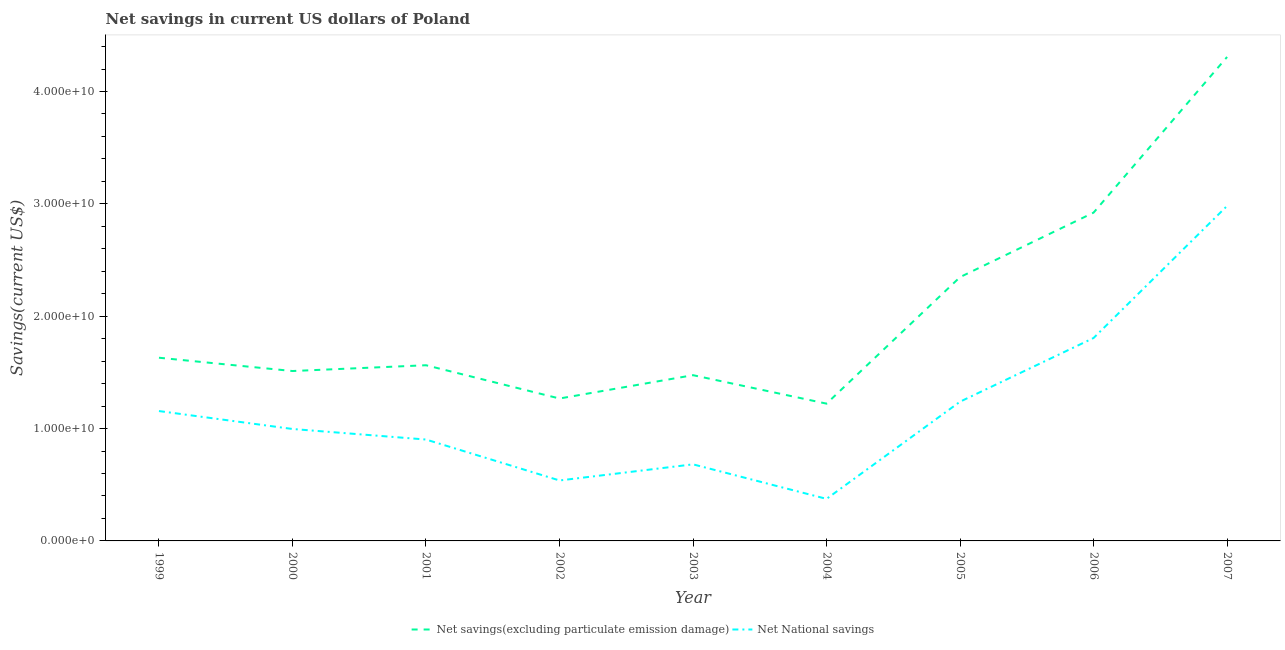Does the line corresponding to net national savings intersect with the line corresponding to net savings(excluding particulate emission damage)?
Ensure brevity in your answer.  No. What is the net national savings in 2002?
Provide a short and direct response. 5.38e+09. Across all years, what is the maximum net national savings?
Provide a short and direct response. 2.98e+1. Across all years, what is the minimum net savings(excluding particulate emission damage)?
Your response must be concise. 1.22e+1. In which year was the net national savings maximum?
Keep it short and to the point. 2007. What is the total net national savings in the graph?
Make the answer very short. 1.07e+11. What is the difference between the net national savings in 2004 and that in 2007?
Your answer should be very brief. -2.61e+1. What is the difference between the net national savings in 2004 and the net savings(excluding particulate emission damage) in 2002?
Make the answer very short. -8.93e+09. What is the average net national savings per year?
Make the answer very short. 1.19e+1. In the year 1999, what is the difference between the net national savings and net savings(excluding particulate emission damage)?
Your response must be concise. -4.75e+09. What is the ratio of the net national savings in 2006 to that in 2007?
Give a very brief answer. 0.61. Is the net savings(excluding particulate emission damage) in 2000 less than that in 2007?
Give a very brief answer. Yes. What is the difference between the highest and the second highest net savings(excluding particulate emission damage)?
Your answer should be very brief. 1.39e+1. What is the difference between the highest and the lowest net savings(excluding particulate emission damage)?
Keep it short and to the point. 3.09e+1. In how many years, is the net savings(excluding particulate emission damage) greater than the average net savings(excluding particulate emission damage) taken over all years?
Ensure brevity in your answer.  3. How many lines are there?
Give a very brief answer. 2. What is the difference between two consecutive major ticks on the Y-axis?
Provide a succinct answer. 1.00e+1. Are the values on the major ticks of Y-axis written in scientific E-notation?
Ensure brevity in your answer.  Yes. Does the graph contain grids?
Keep it short and to the point. No. How are the legend labels stacked?
Your answer should be very brief. Horizontal. What is the title of the graph?
Make the answer very short. Net savings in current US dollars of Poland. Does "Under-5(female)" appear as one of the legend labels in the graph?
Give a very brief answer. No. What is the label or title of the X-axis?
Provide a succinct answer. Year. What is the label or title of the Y-axis?
Your answer should be very brief. Savings(current US$). What is the Savings(current US$) in Net savings(excluding particulate emission damage) in 1999?
Offer a terse response. 1.63e+1. What is the Savings(current US$) of Net National savings in 1999?
Ensure brevity in your answer.  1.16e+1. What is the Savings(current US$) in Net savings(excluding particulate emission damage) in 2000?
Provide a short and direct response. 1.51e+1. What is the Savings(current US$) in Net National savings in 2000?
Give a very brief answer. 9.96e+09. What is the Savings(current US$) of Net savings(excluding particulate emission damage) in 2001?
Keep it short and to the point. 1.56e+1. What is the Savings(current US$) in Net National savings in 2001?
Keep it short and to the point. 9.02e+09. What is the Savings(current US$) in Net savings(excluding particulate emission damage) in 2002?
Offer a terse response. 1.27e+1. What is the Savings(current US$) in Net National savings in 2002?
Your answer should be very brief. 5.38e+09. What is the Savings(current US$) of Net savings(excluding particulate emission damage) in 2003?
Make the answer very short. 1.48e+1. What is the Savings(current US$) in Net National savings in 2003?
Your response must be concise. 6.82e+09. What is the Savings(current US$) in Net savings(excluding particulate emission damage) in 2004?
Provide a succinct answer. 1.22e+1. What is the Savings(current US$) of Net National savings in 2004?
Offer a terse response. 3.74e+09. What is the Savings(current US$) of Net savings(excluding particulate emission damage) in 2005?
Your answer should be very brief. 2.35e+1. What is the Savings(current US$) in Net National savings in 2005?
Your answer should be compact. 1.24e+1. What is the Savings(current US$) of Net savings(excluding particulate emission damage) in 2006?
Give a very brief answer. 2.92e+1. What is the Savings(current US$) of Net National savings in 2006?
Ensure brevity in your answer.  1.81e+1. What is the Savings(current US$) in Net savings(excluding particulate emission damage) in 2007?
Make the answer very short. 4.31e+1. What is the Savings(current US$) in Net National savings in 2007?
Your answer should be very brief. 2.98e+1. Across all years, what is the maximum Savings(current US$) of Net savings(excluding particulate emission damage)?
Give a very brief answer. 4.31e+1. Across all years, what is the maximum Savings(current US$) in Net National savings?
Your response must be concise. 2.98e+1. Across all years, what is the minimum Savings(current US$) in Net savings(excluding particulate emission damage)?
Offer a very short reply. 1.22e+1. Across all years, what is the minimum Savings(current US$) in Net National savings?
Give a very brief answer. 3.74e+09. What is the total Savings(current US$) of Net savings(excluding particulate emission damage) in the graph?
Offer a terse response. 1.82e+11. What is the total Savings(current US$) of Net National savings in the graph?
Your response must be concise. 1.07e+11. What is the difference between the Savings(current US$) in Net savings(excluding particulate emission damage) in 1999 and that in 2000?
Your answer should be very brief. 1.18e+09. What is the difference between the Savings(current US$) in Net National savings in 1999 and that in 2000?
Keep it short and to the point. 1.60e+09. What is the difference between the Savings(current US$) of Net savings(excluding particulate emission damage) in 1999 and that in 2001?
Ensure brevity in your answer.  6.68e+08. What is the difference between the Savings(current US$) of Net National savings in 1999 and that in 2001?
Offer a very short reply. 2.54e+09. What is the difference between the Savings(current US$) in Net savings(excluding particulate emission damage) in 1999 and that in 2002?
Provide a short and direct response. 3.63e+09. What is the difference between the Savings(current US$) in Net National savings in 1999 and that in 2002?
Give a very brief answer. 6.18e+09. What is the difference between the Savings(current US$) in Net savings(excluding particulate emission damage) in 1999 and that in 2003?
Your response must be concise. 1.55e+09. What is the difference between the Savings(current US$) in Net National savings in 1999 and that in 2003?
Provide a succinct answer. 4.74e+09. What is the difference between the Savings(current US$) in Net savings(excluding particulate emission damage) in 1999 and that in 2004?
Offer a terse response. 4.09e+09. What is the difference between the Savings(current US$) of Net National savings in 1999 and that in 2004?
Keep it short and to the point. 7.82e+09. What is the difference between the Savings(current US$) of Net savings(excluding particulate emission damage) in 1999 and that in 2005?
Your answer should be compact. -7.18e+09. What is the difference between the Savings(current US$) of Net National savings in 1999 and that in 2005?
Your response must be concise. -8.35e+08. What is the difference between the Savings(current US$) of Net savings(excluding particulate emission damage) in 1999 and that in 2006?
Offer a terse response. -1.29e+1. What is the difference between the Savings(current US$) of Net National savings in 1999 and that in 2006?
Your answer should be very brief. -6.50e+09. What is the difference between the Savings(current US$) in Net savings(excluding particulate emission damage) in 1999 and that in 2007?
Offer a very short reply. -2.68e+1. What is the difference between the Savings(current US$) of Net National savings in 1999 and that in 2007?
Your answer should be compact. -1.83e+1. What is the difference between the Savings(current US$) of Net savings(excluding particulate emission damage) in 2000 and that in 2001?
Make the answer very short. -5.15e+08. What is the difference between the Savings(current US$) of Net National savings in 2000 and that in 2001?
Your answer should be compact. 9.39e+08. What is the difference between the Savings(current US$) in Net savings(excluding particulate emission damage) in 2000 and that in 2002?
Provide a short and direct response. 2.45e+09. What is the difference between the Savings(current US$) of Net National savings in 2000 and that in 2002?
Your response must be concise. 4.58e+09. What is the difference between the Savings(current US$) of Net savings(excluding particulate emission damage) in 2000 and that in 2003?
Provide a short and direct response. 3.69e+08. What is the difference between the Savings(current US$) in Net National savings in 2000 and that in 2003?
Offer a terse response. 3.15e+09. What is the difference between the Savings(current US$) of Net savings(excluding particulate emission damage) in 2000 and that in 2004?
Offer a terse response. 2.90e+09. What is the difference between the Savings(current US$) in Net National savings in 2000 and that in 2004?
Give a very brief answer. 6.22e+09. What is the difference between the Savings(current US$) in Net savings(excluding particulate emission damage) in 2000 and that in 2005?
Provide a short and direct response. -8.36e+09. What is the difference between the Savings(current US$) in Net National savings in 2000 and that in 2005?
Make the answer very short. -2.43e+09. What is the difference between the Savings(current US$) in Net savings(excluding particulate emission damage) in 2000 and that in 2006?
Give a very brief answer. -1.41e+1. What is the difference between the Savings(current US$) in Net National savings in 2000 and that in 2006?
Provide a short and direct response. -8.10e+09. What is the difference between the Savings(current US$) in Net savings(excluding particulate emission damage) in 2000 and that in 2007?
Your answer should be very brief. -2.80e+1. What is the difference between the Savings(current US$) in Net National savings in 2000 and that in 2007?
Provide a succinct answer. -1.99e+1. What is the difference between the Savings(current US$) of Net savings(excluding particulate emission damage) in 2001 and that in 2002?
Offer a very short reply. 2.96e+09. What is the difference between the Savings(current US$) of Net National savings in 2001 and that in 2002?
Provide a succinct answer. 3.64e+09. What is the difference between the Savings(current US$) of Net savings(excluding particulate emission damage) in 2001 and that in 2003?
Keep it short and to the point. 8.84e+08. What is the difference between the Savings(current US$) in Net National savings in 2001 and that in 2003?
Offer a very short reply. 2.21e+09. What is the difference between the Savings(current US$) in Net savings(excluding particulate emission damage) in 2001 and that in 2004?
Provide a succinct answer. 3.42e+09. What is the difference between the Savings(current US$) in Net National savings in 2001 and that in 2004?
Your answer should be compact. 5.28e+09. What is the difference between the Savings(current US$) in Net savings(excluding particulate emission damage) in 2001 and that in 2005?
Make the answer very short. -7.85e+09. What is the difference between the Savings(current US$) of Net National savings in 2001 and that in 2005?
Provide a short and direct response. -3.37e+09. What is the difference between the Savings(current US$) in Net savings(excluding particulate emission damage) in 2001 and that in 2006?
Make the answer very short. -1.36e+1. What is the difference between the Savings(current US$) in Net National savings in 2001 and that in 2006?
Give a very brief answer. -9.04e+09. What is the difference between the Savings(current US$) in Net savings(excluding particulate emission damage) in 2001 and that in 2007?
Provide a succinct answer. -2.74e+1. What is the difference between the Savings(current US$) of Net National savings in 2001 and that in 2007?
Your answer should be very brief. -2.08e+1. What is the difference between the Savings(current US$) of Net savings(excluding particulate emission damage) in 2002 and that in 2003?
Offer a terse response. -2.08e+09. What is the difference between the Savings(current US$) of Net National savings in 2002 and that in 2003?
Make the answer very short. -1.43e+09. What is the difference between the Savings(current US$) in Net savings(excluding particulate emission damage) in 2002 and that in 2004?
Your response must be concise. 4.56e+08. What is the difference between the Savings(current US$) of Net National savings in 2002 and that in 2004?
Keep it short and to the point. 1.64e+09. What is the difference between the Savings(current US$) of Net savings(excluding particulate emission damage) in 2002 and that in 2005?
Give a very brief answer. -1.08e+1. What is the difference between the Savings(current US$) in Net National savings in 2002 and that in 2005?
Your response must be concise. -7.01e+09. What is the difference between the Savings(current US$) of Net savings(excluding particulate emission damage) in 2002 and that in 2006?
Your answer should be very brief. -1.65e+1. What is the difference between the Savings(current US$) of Net National savings in 2002 and that in 2006?
Your response must be concise. -1.27e+1. What is the difference between the Savings(current US$) of Net savings(excluding particulate emission damage) in 2002 and that in 2007?
Offer a terse response. -3.04e+1. What is the difference between the Savings(current US$) in Net National savings in 2002 and that in 2007?
Provide a short and direct response. -2.44e+1. What is the difference between the Savings(current US$) in Net savings(excluding particulate emission damage) in 2003 and that in 2004?
Give a very brief answer. 2.53e+09. What is the difference between the Savings(current US$) of Net National savings in 2003 and that in 2004?
Your response must be concise. 3.07e+09. What is the difference between the Savings(current US$) of Net savings(excluding particulate emission damage) in 2003 and that in 2005?
Your response must be concise. -8.73e+09. What is the difference between the Savings(current US$) in Net National savings in 2003 and that in 2005?
Provide a succinct answer. -5.58e+09. What is the difference between the Savings(current US$) of Net savings(excluding particulate emission damage) in 2003 and that in 2006?
Offer a terse response. -1.45e+1. What is the difference between the Savings(current US$) in Net National savings in 2003 and that in 2006?
Provide a short and direct response. -1.12e+1. What is the difference between the Savings(current US$) of Net savings(excluding particulate emission damage) in 2003 and that in 2007?
Give a very brief answer. -2.83e+1. What is the difference between the Savings(current US$) of Net National savings in 2003 and that in 2007?
Provide a succinct answer. -2.30e+1. What is the difference between the Savings(current US$) of Net savings(excluding particulate emission damage) in 2004 and that in 2005?
Give a very brief answer. -1.13e+1. What is the difference between the Savings(current US$) of Net National savings in 2004 and that in 2005?
Provide a short and direct response. -8.65e+09. What is the difference between the Savings(current US$) in Net savings(excluding particulate emission damage) in 2004 and that in 2006?
Your response must be concise. -1.70e+1. What is the difference between the Savings(current US$) of Net National savings in 2004 and that in 2006?
Keep it short and to the point. -1.43e+1. What is the difference between the Savings(current US$) of Net savings(excluding particulate emission damage) in 2004 and that in 2007?
Ensure brevity in your answer.  -3.09e+1. What is the difference between the Savings(current US$) in Net National savings in 2004 and that in 2007?
Provide a succinct answer. -2.61e+1. What is the difference between the Savings(current US$) of Net savings(excluding particulate emission damage) in 2005 and that in 2006?
Offer a terse response. -5.74e+09. What is the difference between the Savings(current US$) of Net National savings in 2005 and that in 2006?
Offer a terse response. -5.67e+09. What is the difference between the Savings(current US$) of Net savings(excluding particulate emission damage) in 2005 and that in 2007?
Give a very brief answer. -1.96e+1. What is the difference between the Savings(current US$) in Net National savings in 2005 and that in 2007?
Ensure brevity in your answer.  -1.74e+1. What is the difference between the Savings(current US$) of Net savings(excluding particulate emission damage) in 2006 and that in 2007?
Offer a terse response. -1.39e+1. What is the difference between the Savings(current US$) in Net National savings in 2006 and that in 2007?
Your response must be concise. -1.18e+1. What is the difference between the Savings(current US$) in Net savings(excluding particulate emission damage) in 1999 and the Savings(current US$) in Net National savings in 2000?
Give a very brief answer. 6.34e+09. What is the difference between the Savings(current US$) of Net savings(excluding particulate emission damage) in 1999 and the Savings(current US$) of Net National savings in 2001?
Your answer should be very brief. 7.28e+09. What is the difference between the Savings(current US$) of Net savings(excluding particulate emission damage) in 1999 and the Savings(current US$) of Net National savings in 2002?
Ensure brevity in your answer.  1.09e+1. What is the difference between the Savings(current US$) of Net savings(excluding particulate emission damage) in 1999 and the Savings(current US$) of Net National savings in 2003?
Offer a terse response. 9.49e+09. What is the difference between the Savings(current US$) of Net savings(excluding particulate emission damage) in 1999 and the Savings(current US$) of Net National savings in 2004?
Your response must be concise. 1.26e+1. What is the difference between the Savings(current US$) in Net savings(excluding particulate emission damage) in 1999 and the Savings(current US$) in Net National savings in 2005?
Your answer should be very brief. 3.91e+09. What is the difference between the Savings(current US$) in Net savings(excluding particulate emission damage) in 1999 and the Savings(current US$) in Net National savings in 2006?
Your answer should be compact. -1.76e+09. What is the difference between the Savings(current US$) of Net savings(excluding particulate emission damage) in 1999 and the Savings(current US$) of Net National savings in 2007?
Give a very brief answer. -1.35e+1. What is the difference between the Savings(current US$) in Net savings(excluding particulate emission damage) in 2000 and the Savings(current US$) in Net National savings in 2001?
Your response must be concise. 6.10e+09. What is the difference between the Savings(current US$) in Net savings(excluding particulate emission damage) in 2000 and the Savings(current US$) in Net National savings in 2002?
Make the answer very short. 9.74e+09. What is the difference between the Savings(current US$) of Net savings(excluding particulate emission damage) in 2000 and the Savings(current US$) of Net National savings in 2003?
Ensure brevity in your answer.  8.31e+09. What is the difference between the Savings(current US$) of Net savings(excluding particulate emission damage) in 2000 and the Savings(current US$) of Net National savings in 2004?
Your answer should be very brief. 1.14e+1. What is the difference between the Savings(current US$) of Net savings(excluding particulate emission damage) in 2000 and the Savings(current US$) of Net National savings in 2005?
Keep it short and to the point. 2.73e+09. What is the difference between the Savings(current US$) of Net savings(excluding particulate emission damage) in 2000 and the Savings(current US$) of Net National savings in 2006?
Give a very brief answer. -2.94e+09. What is the difference between the Savings(current US$) in Net savings(excluding particulate emission damage) in 2000 and the Savings(current US$) in Net National savings in 2007?
Ensure brevity in your answer.  -1.47e+1. What is the difference between the Savings(current US$) of Net savings(excluding particulate emission damage) in 2001 and the Savings(current US$) of Net National savings in 2002?
Provide a short and direct response. 1.03e+1. What is the difference between the Savings(current US$) of Net savings(excluding particulate emission damage) in 2001 and the Savings(current US$) of Net National savings in 2003?
Ensure brevity in your answer.  8.82e+09. What is the difference between the Savings(current US$) in Net savings(excluding particulate emission damage) in 2001 and the Savings(current US$) in Net National savings in 2004?
Your answer should be very brief. 1.19e+1. What is the difference between the Savings(current US$) in Net savings(excluding particulate emission damage) in 2001 and the Savings(current US$) in Net National savings in 2005?
Your answer should be compact. 3.24e+09. What is the difference between the Savings(current US$) of Net savings(excluding particulate emission damage) in 2001 and the Savings(current US$) of Net National savings in 2006?
Provide a short and direct response. -2.42e+09. What is the difference between the Savings(current US$) in Net savings(excluding particulate emission damage) in 2001 and the Savings(current US$) in Net National savings in 2007?
Provide a succinct answer. -1.42e+1. What is the difference between the Savings(current US$) in Net savings(excluding particulate emission damage) in 2002 and the Savings(current US$) in Net National savings in 2003?
Keep it short and to the point. 5.86e+09. What is the difference between the Savings(current US$) in Net savings(excluding particulate emission damage) in 2002 and the Savings(current US$) in Net National savings in 2004?
Provide a succinct answer. 8.93e+09. What is the difference between the Savings(current US$) in Net savings(excluding particulate emission damage) in 2002 and the Savings(current US$) in Net National savings in 2005?
Offer a very short reply. 2.82e+08. What is the difference between the Savings(current US$) of Net savings(excluding particulate emission damage) in 2002 and the Savings(current US$) of Net National savings in 2006?
Ensure brevity in your answer.  -5.39e+09. What is the difference between the Savings(current US$) of Net savings(excluding particulate emission damage) in 2002 and the Savings(current US$) of Net National savings in 2007?
Provide a succinct answer. -1.71e+1. What is the difference between the Savings(current US$) of Net savings(excluding particulate emission damage) in 2003 and the Savings(current US$) of Net National savings in 2004?
Your answer should be compact. 1.10e+1. What is the difference between the Savings(current US$) of Net savings(excluding particulate emission damage) in 2003 and the Savings(current US$) of Net National savings in 2005?
Provide a succinct answer. 2.36e+09. What is the difference between the Savings(current US$) of Net savings(excluding particulate emission damage) in 2003 and the Savings(current US$) of Net National savings in 2006?
Provide a short and direct response. -3.31e+09. What is the difference between the Savings(current US$) of Net savings(excluding particulate emission damage) in 2003 and the Savings(current US$) of Net National savings in 2007?
Give a very brief answer. -1.51e+1. What is the difference between the Savings(current US$) of Net savings(excluding particulate emission damage) in 2004 and the Savings(current US$) of Net National savings in 2005?
Make the answer very short. -1.74e+08. What is the difference between the Savings(current US$) of Net savings(excluding particulate emission damage) in 2004 and the Savings(current US$) of Net National savings in 2006?
Provide a short and direct response. -5.84e+09. What is the difference between the Savings(current US$) in Net savings(excluding particulate emission damage) in 2004 and the Savings(current US$) in Net National savings in 2007?
Give a very brief answer. -1.76e+1. What is the difference between the Savings(current US$) in Net savings(excluding particulate emission damage) in 2005 and the Savings(current US$) in Net National savings in 2006?
Ensure brevity in your answer.  5.42e+09. What is the difference between the Savings(current US$) of Net savings(excluding particulate emission damage) in 2005 and the Savings(current US$) of Net National savings in 2007?
Provide a succinct answer. -6.34e+09. What is the difference between the Savings(current US$) in Net savings(excluding particulate emission damage) in 2006 and the Savings(current US$) in Net National savings in 2007?
Offer a very short reply. -5.99e+08. What is the average Savings(current US$) in Net savings(excluding particulate emission damage) per year?
Give a very brief answer. 2.03e+1. What is the average Savings(current US$) of Net National savings per year?
Offer a terse response. 1.19e+1. In the year 1999, what is the difference between the Savings(current US$) in Net savings(excluding particulate emission damage) and Savings(current US$) in Net National savings?
Offer a very short reply. 4.75e+09. In the year 2000, what is the difference between the Savings(current US$) in Net savings(excluding particulate emission damage) and Savings(current US$) in Net National savings?
Ensure brevity in your answer.  5.16e+09. In the year 2001, what is the difference between the Savings(current US$) of Net savings(excluding particulate emission damage) and Savings(current US$) of Net National savings?
Offer a very short reply. 6.61e+09. In the year 2002, what is the difference between the Savings(current US$) in Net savings(excluding particulate emission damage) and Savings(current US$) in Net National savings?
Provide a short and direct response. 7.29e+09. In the year 2003, what is the difference between the Savings(current US$) of Net savings(excluding particulate emission damage) and Savings(current US$) of Net National savings?
Give a very brief answer. 7.94e+09. In the year 2004, what is the difference between the Savings(current US$) in Net savings(excluding particulate emission damage) and Savings(current US$) in Net National savings?
Give a very brief answer. 8.48e+09. In the year 2005, what is the difference between the Savings(current US$) of Net savings(excluding particulate emission damage) and Savings(current US$) of Net National savings?
Your response must be concise. 1.11e+1. In the year 2006, what is the difference between the Savings(current US$) of Net savings(excluding particulate emission damage) and Savings(current US$) of Net National savings?
Make the answer very short. 1.12e+1. In the year 2007, what is the difference between the Savings(current US$) in Net savings(excluding particulate emission damage) and Savings(current US$) in Net National savings?
Provide a short and direct response. 1.33e+1. What is the ratio of the Savings(current US$) of Net savings(excluding particulate emission damage) in 1999 to that in 2000?
Make the answer very short. 1.08. What is the ratio of the Savings(current US$) in Net National savings in 1999 to that in 2000?
Your answer should be compact. 1.16. What is the ratio of the Savings(current US$) in Net savings(excluding particulate emission damage) in 1999 to that in 2001?
Provide a succinct answer. 1.04. What is the ratio of the Savings(current US$) of Net National savings in 1999 to that in 2001?
Ensure brevity in your answer.  1.28. What is the ratio of the Savings(current US$) in Net savings(excluding particulate emission damage) in 1999 to that in 2002?
Provide a succinct answer. 1.29. What is the ratio of the Savings(current US$) of Net National savings in 1999 to that in 2002?
Ensure brevity in your answer.  2.15. What is the ratio of the Savings(current US$) of Net savings(excluding particulate emission damage) in 1999 to that in 2003?
Your response must be concise. 1.11. What is the ratio of the Savings(current US$) in Net National savings in 1999 to that in 2003?
Offer a terse response. 1.7. What is the ratio of the Savings(current US$) of Net savings(excluding particulate emission damage) in 1999 to that in 2004?
Your answer should be very brief. 1.33. What is the ratio of the Savings(current US$) in Net National savings in 1999 to that in 2004?
Provide a succinct answer. 3.09. What is the ratio of the Savings(current US$) in Net savings(excluding particulate emission damage) in 1999 to that in 2005?
Your answer should be very brief. 0.69. What is the ratio of the Savings(current US$) of Net National savings in 1999 to that in 2005?
Offer a terse response. 0.93. What is the ratio of the Savings(current US$) of Net savings(excluding particulate emission damage) in 1999 to that in 2006?
Your answer should be very brief. 0.56. What is the ratio of the Savings(current US$) of Net National savings in 1999 to that in 2006?
Provide a short and direct response. 0.64. What is the ratio of the Savings(current US$) of Net savings(excluding particulate emission damage) in 1999 to that in 2007?
Provide a succinct answer. 0.38. What is the ratio of the Savings(current US$) of Net National savings in 1999 to that in 2007?
Make the answer very short. 0.39. What is the ratio of the Savings(current US$) in Net National savings in 2000 to that in 2001?
Provide a succinct answer. 1.1. What is the ratio of the Savings(current US$) of Net savings(excluding particulate emission damage) in 2000 to that in 2002?
Ensure brevity in your answer.  1.19. What is the ratio of the Savings(current US$) in Net National savings in 2000 to that in 2002?
Give a very brief answer. 1.85. What is the ratio of the Savings(current US$) in Net National savings in 2000 to that in 2003?
Provide a succinct answer. 1.46. What is the ratio of the Savings(current US$) in Net savings(excluding particulate emission damage) in 2000 to that in 2004?
Your answer should be very brief. 1.24. What is the ratio of the Savings(current US$) of Net National savings in 2000 to that in 2004?
Provide a succinct answer. 2.66. What is the ratio of the Savings(current US$) of Net savings(excluding particulate emission damage) in 2000 to that in 2005?
Make the answer very short. 0.64. What is the ratio of the Savings(current US$) of Net National savings in 2000 to that in 2005?
Offer a terse response. 0.8. What is the ratio of the Savings(current US$) in Net savings(excluding particulate emission damage) in 2000 to that in 2006?
Keep it short and to the point. 0.52. What is the ratio of the Savings(current US$) in Net National savings in 2000 to that in 2006?
Keep it short and to the point. 0.55. What is the ratio of the Savings(current US$) of Net savings(excluding particulate emission damage) in 2000 to that in 2007?
Provide a short and direct response. 0.35. What is the ratio of the Savings(current US$) in Net National savings in 2000 to that in 2007?
Your answer should be very brief. 0.33. What is the ratio of the Savings(current US$) in Net savings(excluding particulate emission damage) in 2001 to that in 2002?
Offer a very short reply. 1.23. What is the ratio of the Savings(current US$) of Net National savings in 2001 to that in 2002?
Provide a succinct answer. 1.68. What is the ratio of the Savings(current US$) of Net savings(excluding particulate emission damage) in 2001 to that in 2003?
Provide a short and direct response. 1.06. What is the ratio of the Savings(current US$) in Net National savings in 2001 to that in 2003?
Offer a terse response. 1.32. What is the ratio of the Savings(current US$) in Net savings(excluding particulate emission damage) in 2001 to that in 2004?
Offer a terse response. 1.28. What is the ratio of the Savings(current US$) in Net National savings in 2001 to that in 2004?
Offer a very short reply. 2.41. What is the ratio of the Savings(current US$) in Net savings(excluding particulate emission damage) in 2001 to that in 2005?
Offer a very short reply. 0.67. What is the ratio of the Savings(current US$) of Net National savings in 2001 to that in 2005?
Keep it short and to the point. 0.73. What is the ratio of the Savings(current US$) in Net savings(excluding particulate emission damage) in 2001 to that in 2006?
Provide a succinct answer. 0.54. What is the ratio of the Savings(current US$) of Net National savings in 2001 to that in 2006?
Your answer should be very brief. 0.5. What is the ratio of the Savings(current US$) of Net savings(excluding particulate emission damage) in 2001 to that in 2007?
Your answer should be compact. 0.36. What is the ratio of the Savings(current US$) in Net National savings in 2001 to that in 2007?
Your response must be concise. 0.3. What is the ratio of the Savings(current US$) in Net savings(excluding particulate emission damage) in 2002 to that in 2003?
Offer a very short reply. 0.86. What is the ratio of the Savings(current US$) in Net National savings in 2002 to that in 2003?
Provide a succinct answer. 0.79. What is the ratio of the Savings(current US$) of Net savings(excluding particulate emission damage) in 2002 to that in 2004?
Provide a succinct answer. 1.04. What is the ratio of the Savings(current US$) in Net National savings in 2002 to that in 2004?
Offer a very short reply. 1.44. What is the ratio of the Savings(current US$) in Net savings(excluding particulate emission damage) in 2002 to that in 2005?
Provide a succinct answer. 0.54. What is the ratio of the Savings(current US$) in Net National savings in 2002 to that in 2005?
Give a very brief answer. 0.43. What is the ratio of the Savings(current US$) of Net savings(excluding particulate emission damage) in 2002 to that in 2006?
Your response must be concise. 0.43. What is the ratio of the Savings(current US$) in Net National savings in 2002 to that in 2006?
Provide a short and direct response. 0.3. What is the ratio of the Savings(current US$) in Net savings(excluding particulate emission damage) in 2002 to that in 2007?
Ensure brevity in your answer.  0.29. What is the ratio of the Savings(current US$) in Net National savings in 2002 to that in 2007?
Provide a short and direct response. 0.18. What is the ratio of the Savings(current US$) in Net savings(excluding particulate emission damage) in 2003 to that in 2004?
Ensure brevity in your answer.  1.21. What is the ratio of the Savings(current US$) of Net National savings in 2003 to that in 2004?
Your answer should be compact. 1.82. What is the ratio of the Savings(current US$) of Net savings(excluding particulate emission damage) in 2003 to that in 2005?
Give a very brief answer. 0.63. What is the ratio of the Savings(current US$) of Net National savings in 2003 to that in 2005?
Your response must be concise. 0.55. What is the ratio of the Savings(current US$) in Net savings(excluding particulate emission damage) in 2003 to that in 2006?
Offer a very short reply. 0.5. What is the ratio of the Savings(current US$) of Net National savings in 2003 to that in 2006?
Provide a succinct answer. 0.38. What is the ratio of the Savings(current US$) of Net savings(excluding particulate emission damage) in 2003 to that in 2007?
Make the answer very short. 0.34. What is the ratio of the Savings(current US$) of Net National savings in 2003 to that in 2007?
Ensure brevity in your answer.  0.23. What is the ratio of the Savings(current US$) of Net savings(excluding particulate emission damage) in 2004 to that in 2005?
Provide a short and direct response. 0.52. What is the ratio of the Savings(current US$) in Net National savings in 2004 to that in 2005?
Your response must be concise. 0.3. What is the ratio of the Savings(current US$) of Net savings(excluding particulate emission damage) in 2004 to that in 2006?
Your answer should be compact. 0.42. What is the ratio of the Savings(current US$) of Net National savings in 2004 to that in 2006?
Give a very brief answer. 0.21. What is the ratio of the Savings(current US$) of Net savings(excluding particulate emission damage) in 2004 to that in 2007?
Offer a very short reply. 0.28. What is the ratio of the Savings(current US$) of Net National savings in 2004 to that in 2007?
Provide a succinct answer. 0.13. What is the ratio of the Savings(current US$) in Net savings(excluding particulate emission damage) in 2005 to that in 2006?
Your response must be concise. 0.8. What is the ratio of the Savings(current US$) of Net National savings in 2005 to that in 2006?
Offer a terse response. 0.69. What is the ratio of the Savings(current US$) of Net savings(excluding particulate emission damage) in 2005 to that in 2007?
Make the answer very short. 0.55. What is the ratio of the Savings(current US$) in Net National savings in 2005 to that in 2007?
Your response must be concise. 0.42. What is the ratio of the Savings(current US$) of Net savings(excluding particulate emission damage) in 2006 to that in 2007?
Provide a succinct answer. 0.68. What is the ratio of the Savings(current US$) in Net National savings in 2006 to that in 2007?
Your answer should be very brief. 0.61. What is the difference between the highest and the second highest Savings(current US$) of Net savings(excluding particulate emission damage)?
Keep it short and to the point. 1.39e+1. What is the difference between the highest and the second highest Savings(current US$) in Net National savings?
Your answer should be very brief. 1.18e+1. What is the difference between the highest and the lowest Savings(current US$) in Net savings(excluding particulate emission damage)?
Offer a terse response. 3.09e+1. What is the difference between the highest and the lowest Savings(current US$) of Net National savings?
Make the answer very short. 2.61e+1. 